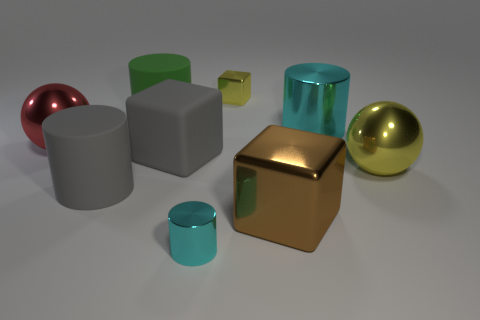Add 1 big gray blocks. How many objects exist? 10 Subtract all cylinders. How many objects are left? 5 Add 3 big yellow shiny cubes. How many big yellow shiny cubes exist? 3 Subtract 0 gray balls. How many objects are left? 9 Subtract all big shiny spheres. Subtract all large gray matte cylinders. How many objects are left? 6 Add 2 large brown blocks. How many large brown blocks are left? 3 